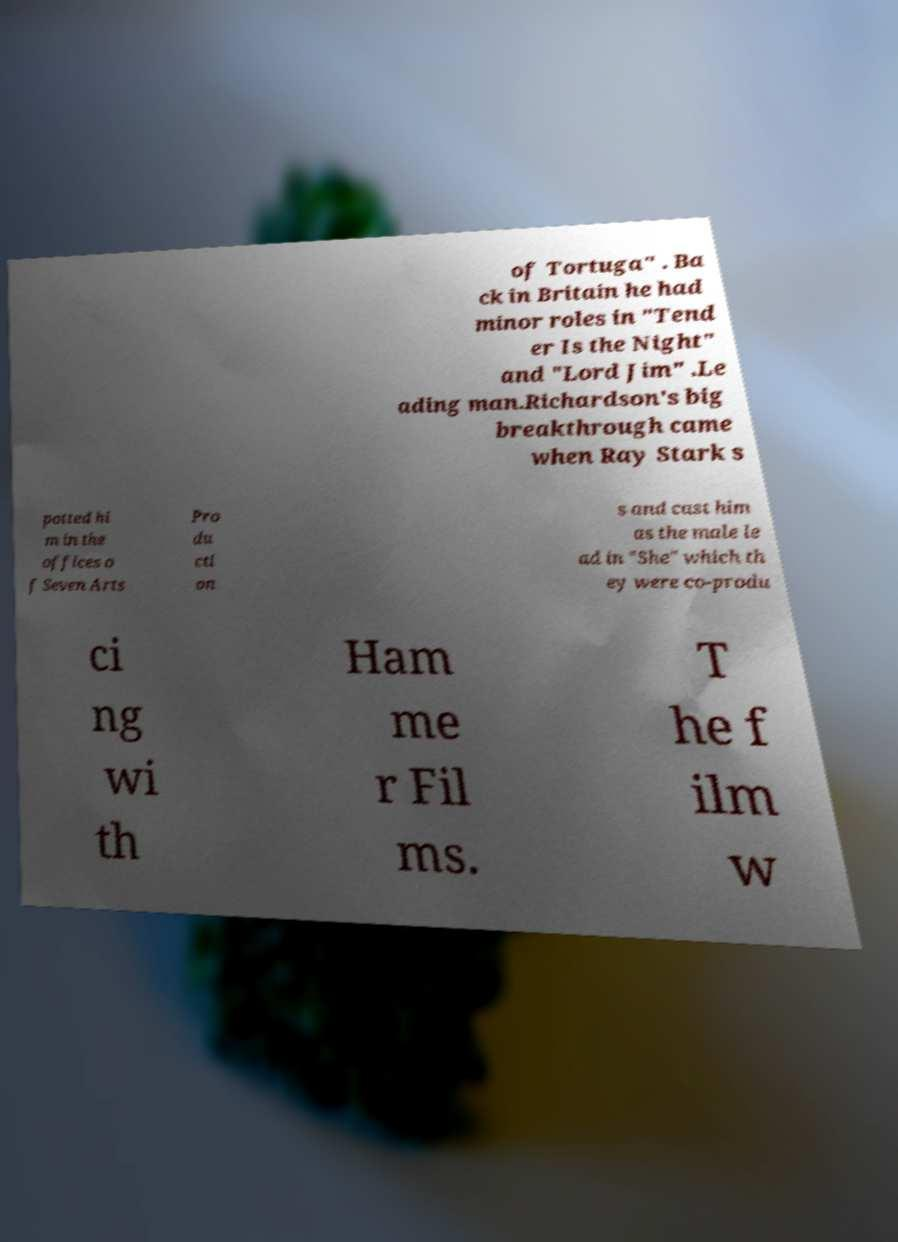Can you read and provide the text displayed in the image?This photo seems to have some interesting text. Can you extract and type it out for me? of Tortuga" . Ba ck in Britain he had minor roles in "Tend er Is the Night" and "Lord Jim" .Le ading man.Richardson's big breakthrough came when Ray Stark s potted hi m in the offices o f Seven Arts Pro du cti on s and cast him as the male le ad in "She" which th ey were co-produ ci ng wi th Ham me r Fil ms. T he f ilm w 